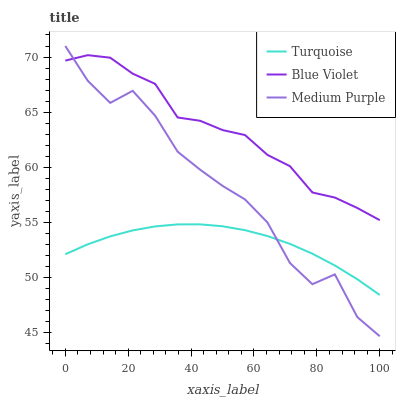Does Turquoise have the minimum area under the curve?
Answer yes or no. Yes. Does Blue Violet have the maximum area under the curve?
Answer yes or no. Yes. Does Blue Violet have the minimum area under the curve?
Answer yes or no. No. Does Turquoise have the maximum area under the curve?
Answer yes or no. No. Is Turquoise the smoothest?
Answer yes or no. Yes. Is Medium Purple the roughest?
Answer yes or no. Yes. Is Blue Violet the smoothest?
Answer yes or no. No. Is Blue Violet the roughest?
Answer yes or no. No. Does Turquoise have the lowest value?
Answer yes or no. No. Does Medium Purple have the highest value?
Answer yes or no. Yes. Does Blue Violet have the highest value?
Answer yes or no. No. Is Turquoise less than Blue Violet?
Answer yes or no. Yes. Is Blue Violet greater than Turquoise?
Answer yes or no. Yes. Does Medium Purple intersect Turquoise?
Answer yes or no. Yes. Is Medium Purple less than Turquoise?
Answer yes or no. No. Is Medium Purple greater than Turquoise?
Answer yes or no. No. Does Turquoise intersect Blue Violet?
Answer yes or no. No. 